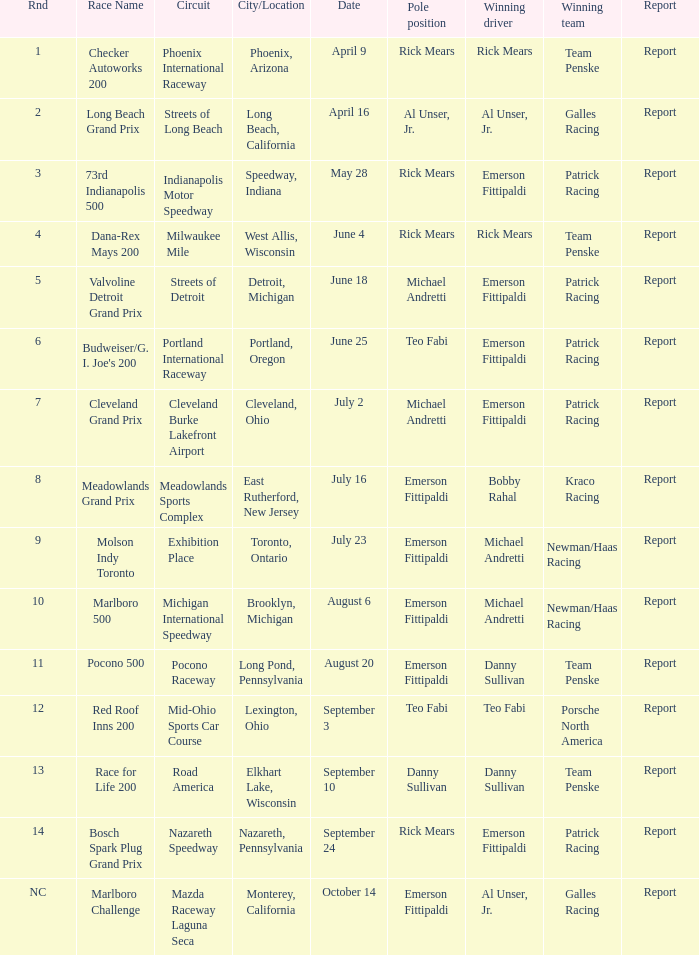What were the rounds at the phoenix international raceway? 1.0. 